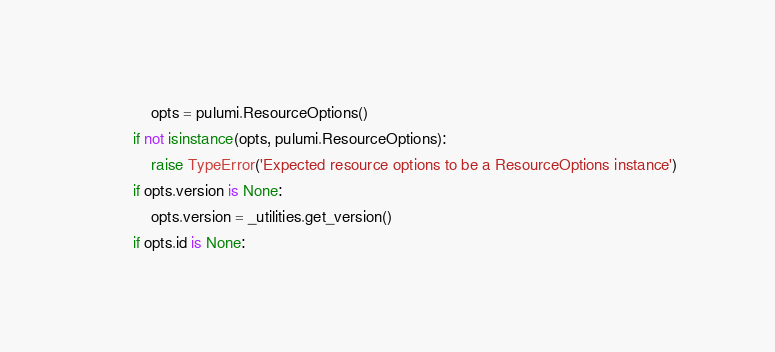Convert code to text. <code><loc_0><loc_0><loc_500><loc_500><_Python_>            opts = pulumi.ResourceOptions()
        if not isinstance(opts, pulumi.ResourceOptions):
            raise TypeError('Expected resource options to be a ResourceOptions instance')
        if opts.version is None:
            opts.version = _utilities.get_version()
        if opts.id is None:</code> 